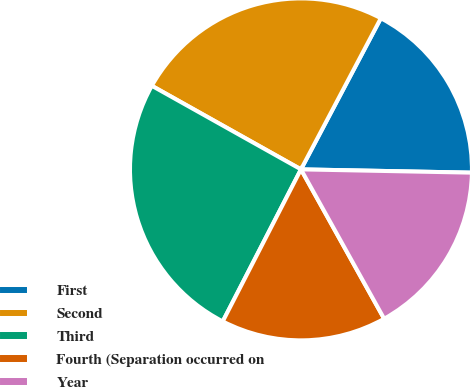<chart> <loc_0><loc_0><loc_500><loc_500><pie_chart><fcel>First<fcel>Second<fcel>Third<fcel>Fourth (Separation occurred on<fcel>Year<nl><fcel>17.57%<fcel>24.61%<fcel>25.57%<fcel>15.65%<fcel>16.61%<nl></chart> 